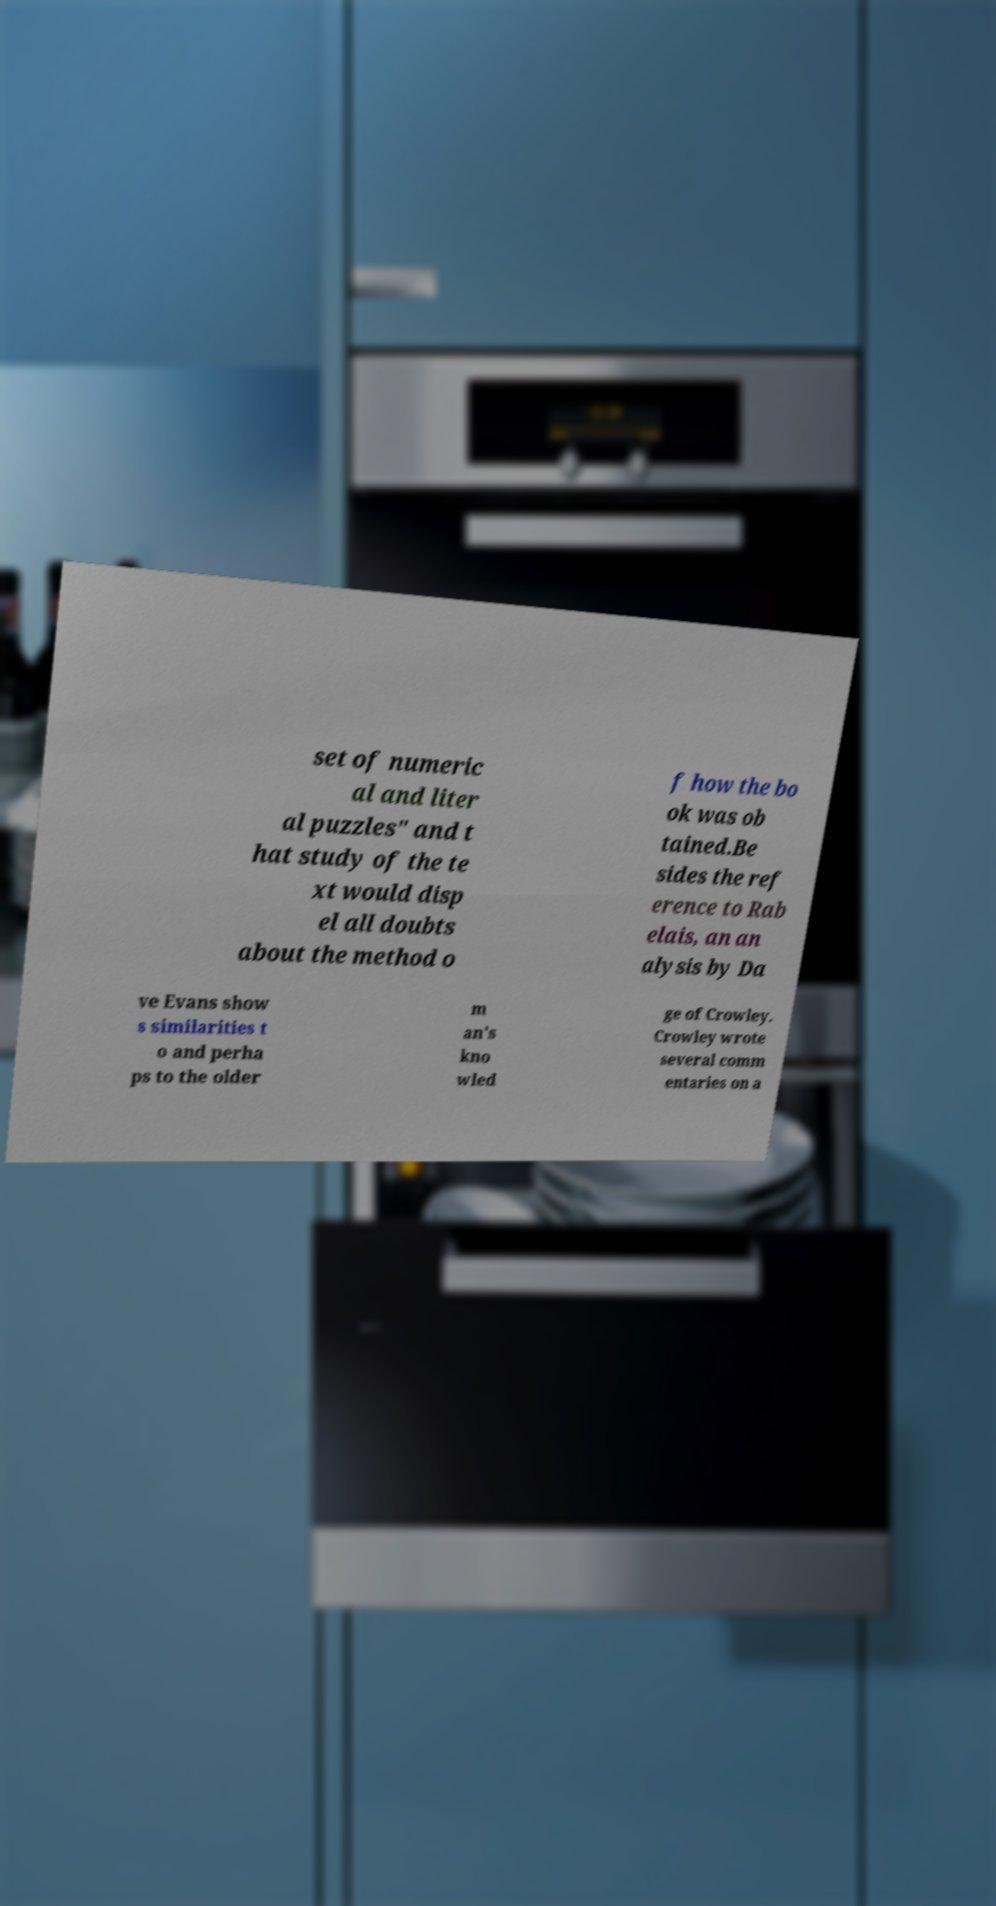I need the written content from this picture converted into text. Can you do that? set of numeric al and liter al puzzles" and t hat study of the te xt would disp el all doubts about the method o f how the bo ok was ob tained.Be sides the ref erence to Rab elais, an an alysis by Da ve Evans show s similarities t o and perha ps to the older m an's kno wled ge of Crowley. Crowley wrote several comm entaries on a 